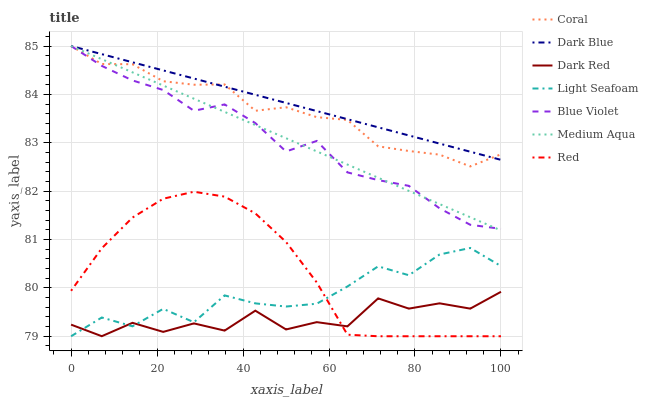Does Dark Red have the minimum area under the curve?
Answer yes or no. Yes. Does Dark Blue have the maximum area under the curve?
Answer yes or no. Yes. Does Coral have the minimum area under the curve?
Answer yes or no. No. Does Coral have the maximum area under the curve?
Answer yes or no. No. Is Dark Blue the smoothest?
Answer yes or no. Yes. Is Dark Red the roughest?
Answer yes or no. Yes. Is Coral the smoothest?
Answer yes or no. No. Is Coral the roughest?
Answer yes or no. No. Does Red have the lowest value?
Answer yes or no. Yes. Does Coral have the lowest value?
Answer yes or no. No. Does Blue Violet have the highest value?
Answer yes or no. Yes. Does Red have the highest value?
Answer yes or no. No. Is Dark Red less than Blue Violet?
Answer yes or no. Yes. Is Medium Aqua greater than Red?
Answer yes or no. Yes. Does Dark Blue intersect Blue Violet?
Answer yes or no. Yes. Is Dark Blue less than Blue Violet?
Answer yes or no. No. Is Dark Blue greater than Blue Violet?
Answer yes or no. No. Does Dark Red intersect Blue Violet?
Answer yes or no. No. 